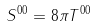Convert formula to latex. <formula><loc_0><loc_0><loc_500><loc_500>S ^ { 0 0 } = 8 \pi T ^ { 0 0 }</formula> 